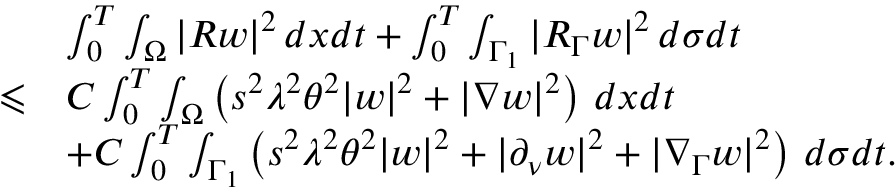Convert formula to latex. <formula><loc_0><loc_0><loc_500><loc_500>\begin{array} { r l } & { \int _ { 0 } ^ { T } \int _ { \Omega } | R w | ^ { 2 } \, d x d t + \int _ { 0 } ^ { T } \int _ { \Gamma _ { 1 } } | R _ { \Gamma } w | ^ { 2 } \, d \sigma d t } \\ { \leqslant } & { C \int _ { 0 } ^ { T } \int _ { \Omega } \left ( s ^ { 2 } \lambda ^ { 2 } \theta ^ { 2 } | w | ^ { 2 } + | \nabla w | ^ { 2 } \right ) \, d x d t } \\ & { + C \int _ { 0 } ^ { T } \int _ { \Gamma _ { 1 } } \left ( s ^ { 2 } \lambda ^ { 2 } \theta ^ { 2 } | w | ^ { 2 } + | \partial _ { \nu } w | ^ { 2 } + | \nabla _ { \Gamma } w | ^ { 2 } \right ) \, d \sigma d t . } \end{array}</formula> 